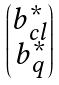<formula> <loc_0><loc_0><loc_500><loc_500>\begin{pmatrix} b ^ { * } _ { c l } \\ b ^ { * } _ { q } \end{pmatrix}</formula> 